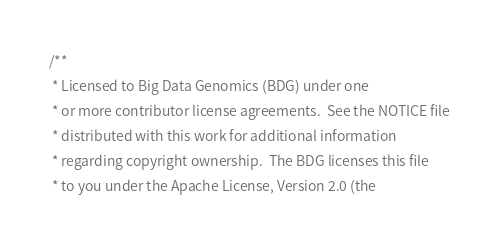Convert code to text. <code><loc_0><loc_0><loc_500><loc_500><_Scala_>/**
 * Licensed to Big Data Genomics (BDG) under one
 * or more contributor license agreements.  See the NOTICE file
 * distributed with this work for additional information
 * regarding copyright ownership.  The BDG licenses this file
 * to you under the Apache License, Version 2.0 (the</code> 